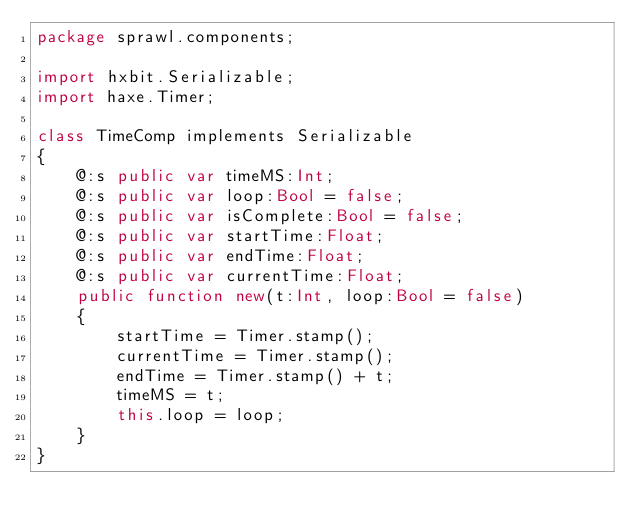<code> <loc_0><loc_0><loc_500><loc_500><_Haxe_>package sprawl.components;

import hxbit.Serializable;
import haxe.Timer;

class TimeComp implements Serializable
{
    @:s public var timeMS:Int;
    @:s public var loop:Bool = false;
    @:s public var isComplete:Bool = false;
    @:s public var startTime:Float;
    @:s public var endTime:Float;
    @:s public var currentTime:Float;
    public function new(t:Int, loop:Bool = false) 
    {
        startTime = Timer.stamp();
        currentTime = Timer.stamp();
        endTime = Timer.stamp() + t;
        timeMS = t;
        this.loop = loop;
    }
}</code> 